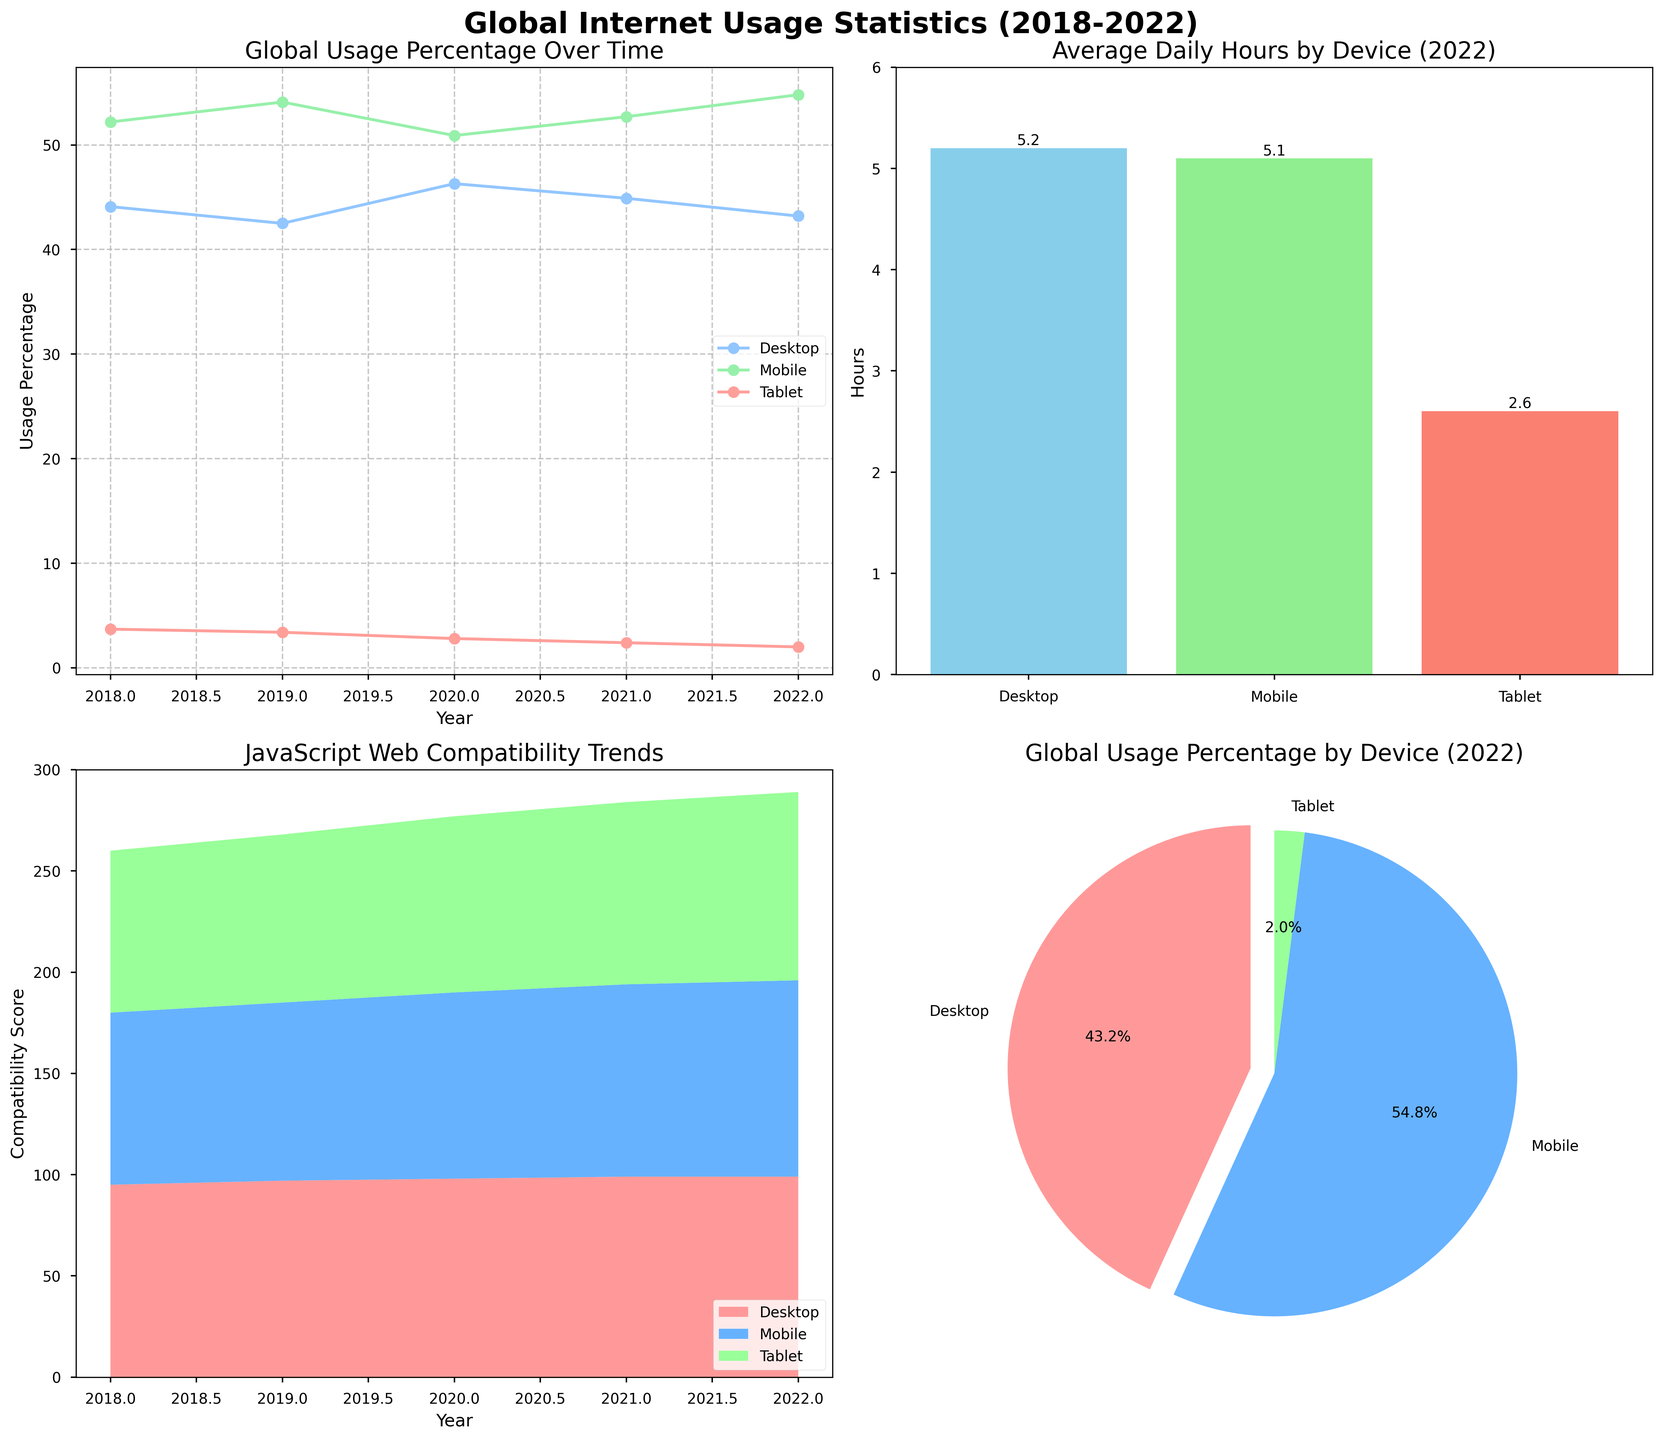What is the title of the entire figure? The title is displayed at the top of the entire figure and reads "Global Internet Usage Statistics (2018-2022)" which summarizes the focus and time span of the data visualized.
Answer: Global Internet Usage Statistics (2018-2022) Which device had the highest global usage percentage in 2022 according to the pie chart? The pie chart shows global usage percentages for 2022 and the largest slice, colored in sky blue, represents mobile devices. The legend confirms this relationship.
Answer: Mobile In the line plot, how did the global usage percentage for tablets change from 2018 to 2022? According to the line plot, tablets show a declining trend, starting from 3.7% in 2018 and ending at 2.0% in 2022.
Answer: Decreased What is the average daily usage of desktop devices in 2022 compared to mobile devices? From the bar chart of average daily hours in 2022, desktop devices averaged 5.2 hours while mobile devices averaged 5.1 hours per day. Comparing these values, desktop usage is slightly higher.
Answer: Desktop is higher Which device had the lowest average daily usage in 2022? The bar chart for 2022 shows the average daily hours for each device, with tablets having the shortest bar among the three devices, indicating the lowest usage.
Answer: Tablet How did JavaScript web compatibility change for mobile devices from 2018 to 2022? The stacked area plot shows a positive trend in JavaScript compatibility scores for mobile devices, increasing from 85 in 2018 to 97 in 2022.
Answer: Increased From the line plot, in which year did desktop devices see the highest global usage percentage? Observing the line plot, desktop devices had the highest global usage percentage in 2020, indicated by the peak of the line.
Answer: 2020 What is the total usage percentage for desktop, mobile, and tablet in 2022 according to the pie chart? The pie chart slices sum to a total percentage, 43.2% (Desktop) + 54.8% (Mobile) + 2.0% (Tablet), which is 100%.
Answer: 100% How does the JavaScript web compatibility of tablets in 2022 compare to that in 2018? Referencing the stacked area plot, the compatibility for tablets started at 80 in 2018 and grew to 93 in 2022, indicating an improvement.
Answer: Increased 